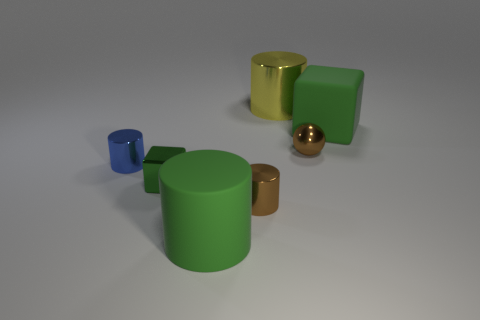Are there any repeating shapes or patterns in the objects pictured? Yes, there are repeating geometric shapes present in the image. The cylindrical shape repeats in both the blue and copper objects, with two sizes for the latter. Additionally, the cube shape is repeated with the two green objects that appear identical in size and shape. 